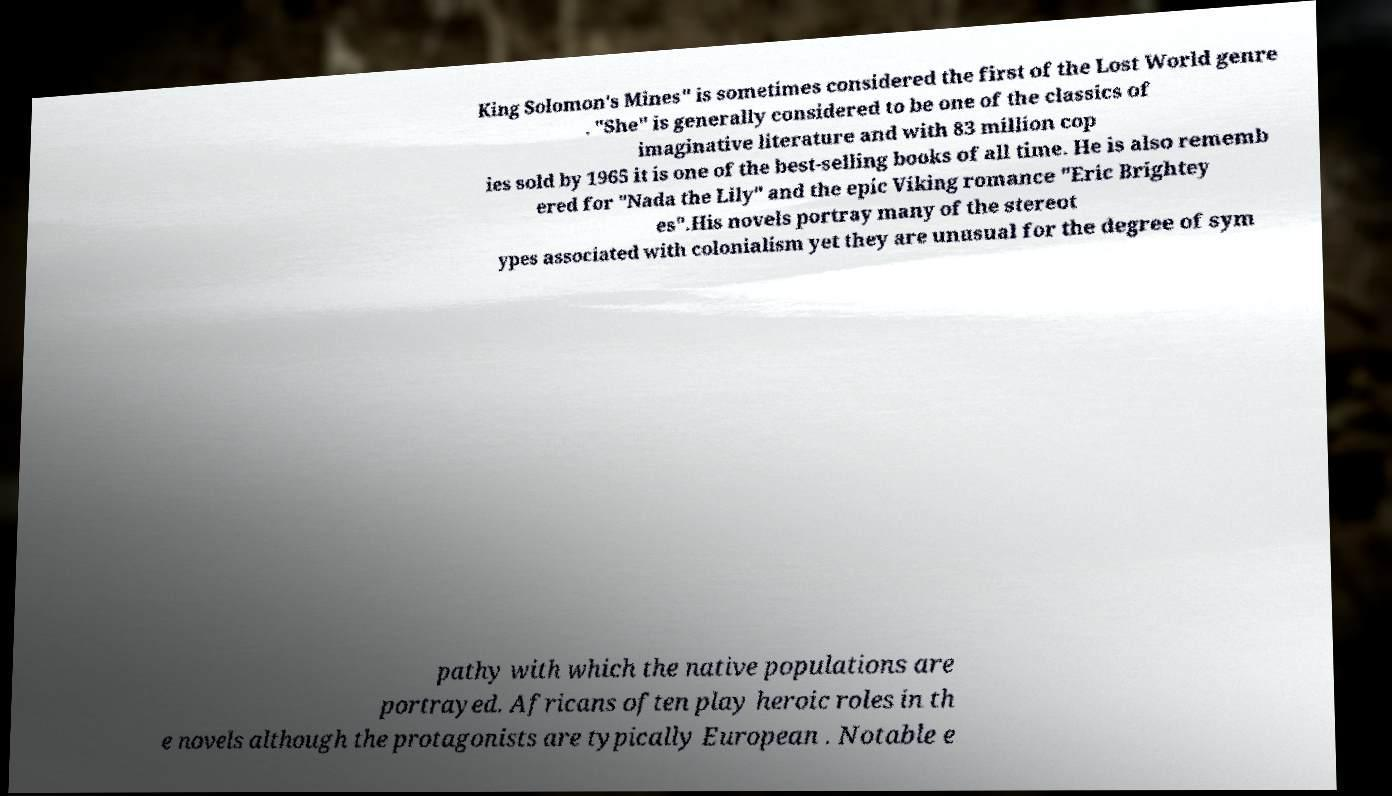What messages or text are displayed in this image? I need them in a readable, typed format. King Solomon's Mines" is sometimes considered the first of the Lost World genre . "She" is generally considered to be one of the classics of imaginative literature and with 83 million cop ies sold by 1965 it is one of the best-selling books of all time. He is also rememb ered for "Nada the Lily" and the epic Viking romance "Eric Brightey es".His novels portray many of the stereot ypes associated with colonialism yet they are unusual for the degree of sym pathy with which the native populations are portrayed. Africans often play heroic roles in th e novels although the protagonists are typically European . Notable e 